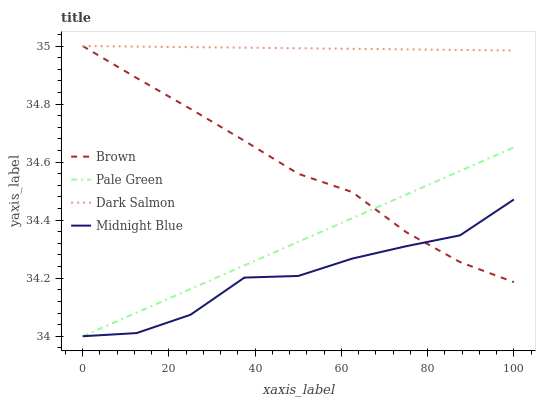Does Midnight Blue have the minimum area under the curve?
Answer yes or no. Yes. Does Dark Salmon have the maximum area under the curve?
Answer yes or no. Yes. Does Pale Green have the minimum area under the curve?
Answer yes or no. No. Does Pale Green have the maximum area under the curve?
Answer yes or no. No. Is Pale Green the smoothest?
Answer yes or no. Yes. Is Midnight Blue the roughest?
Answer yes or no. Yes. Is Dark Salmon the smoothest?
Answer yes or no. No. Is Dark Salmon the roughest?
Answer yes or no. No. Does Dark Salmon have the lowest value?
Answer yes or no. No. Does Pale Green have the highest value?
Answer yes or no. No. Is Midnight Blue less than Dark Salmon?
Answer yes or no. Yes. Is Dark Salmon greater than Pale Green?
Answer yes or no. Yes. Does Midnight Blue intersect Dark Salmon?
Answer yes or no. No. 